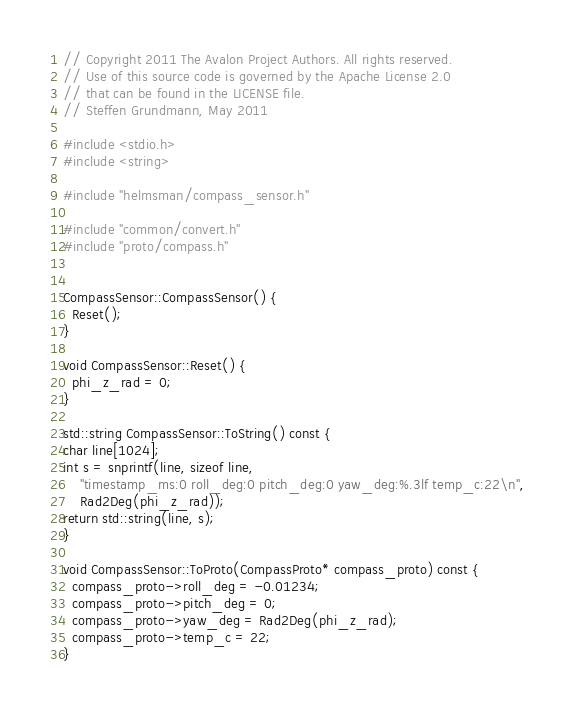<code> <loc_0><loc_0><loc_500><loc_500><_C++_>// Copyright 2011 The Avalon Project Authors. All rights reserved.
// Use of this source code is governed by the Apache License 2.0
// that can be found in the LICENSE file.
// Steffen Grundmann, May 2011

#include <stdio.h>
#include <string>

#include "helmsman/compass_sensor.h"

#include "common/convert.h"
#include "proto/compass.h"


CompassSensor::CompassSensor() {
  Reset();
}

void CompassSensor::Reset() {
  phi_z_rad = 0;
}

std::string CompassSensor::ToString() const {
char line[1024];
int s = snprintf(line, sizeof line,
    "timestamp_ms:0 roll_deg:0 pitch_deg:0 yaw_deg:%.3lf temp_c:22\n",
    Rad2Deg(phi_z_rad));
return std::string(line, s);
}

void CompassSensor::ToProto(CompassProto* compass_proto) const {
  compass_proto->roll_deg = -0.01234;
  compass_proto->pitch_deg = 0;
  compass_proto->yaw_deg = Rad2Deg(phi_z_rad);
  compass_proto->temp_c = 22;
}

</code> 